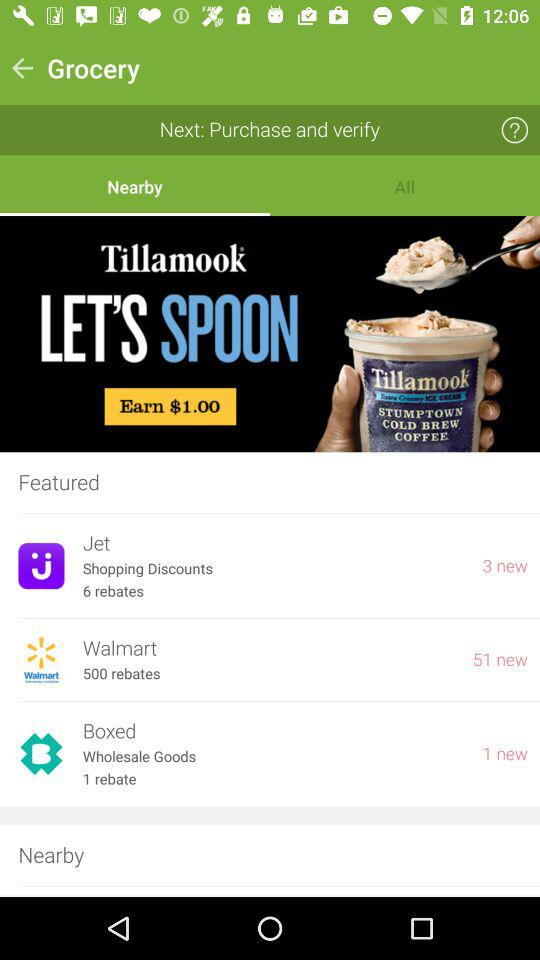How many new features have come for "Jet"? There are 3 new features that have come for "Jet". 